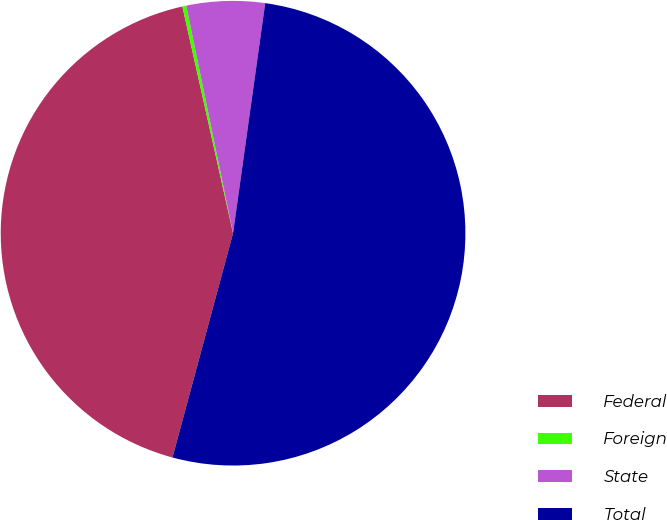Convert chart. <chart><loc_0><loc_0><loc_500><loc_500><pie_chart><fcel>Federal<fcel>Foreign<fcel>State<fcel>Total<nl><fcel>42.3%<fcel>0.27%<fcel>5.44%<fcel>51.99%<nl></chart> 